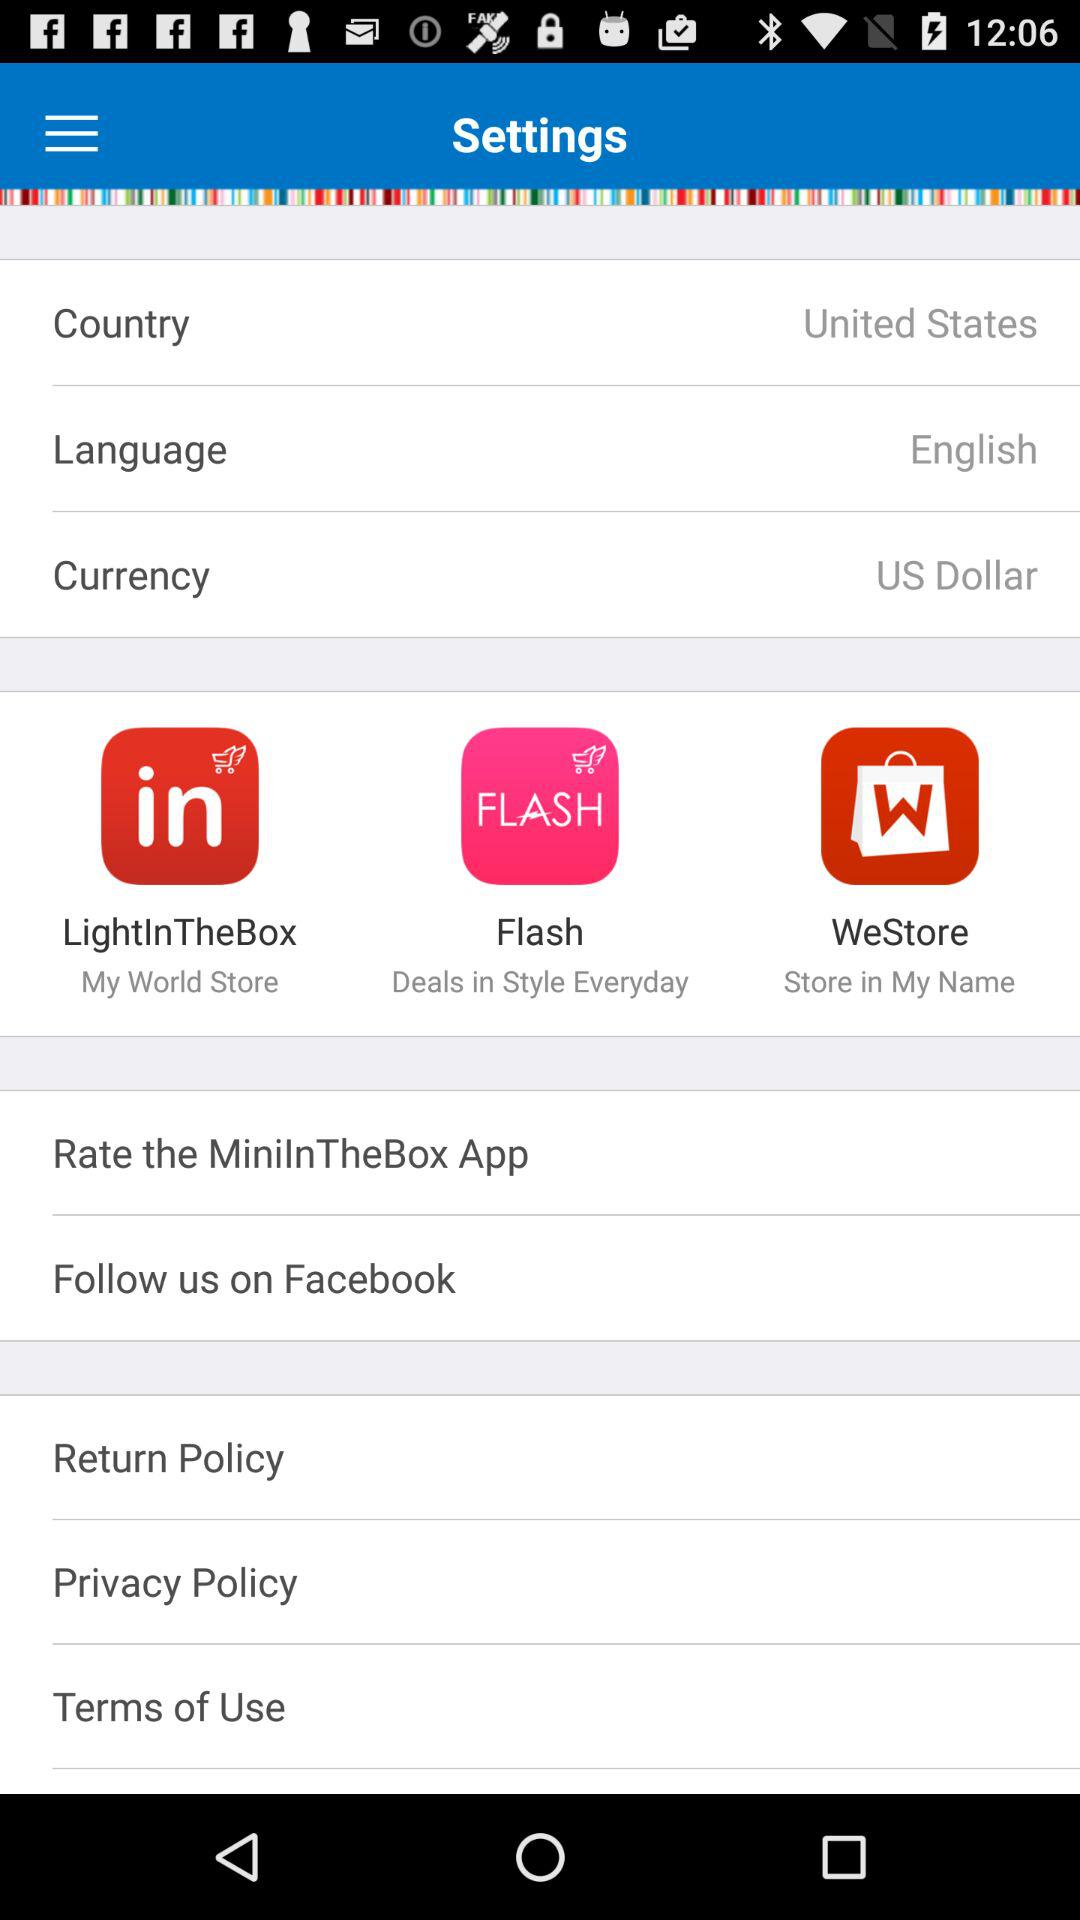Which country is selected? The selected country is the United States. 